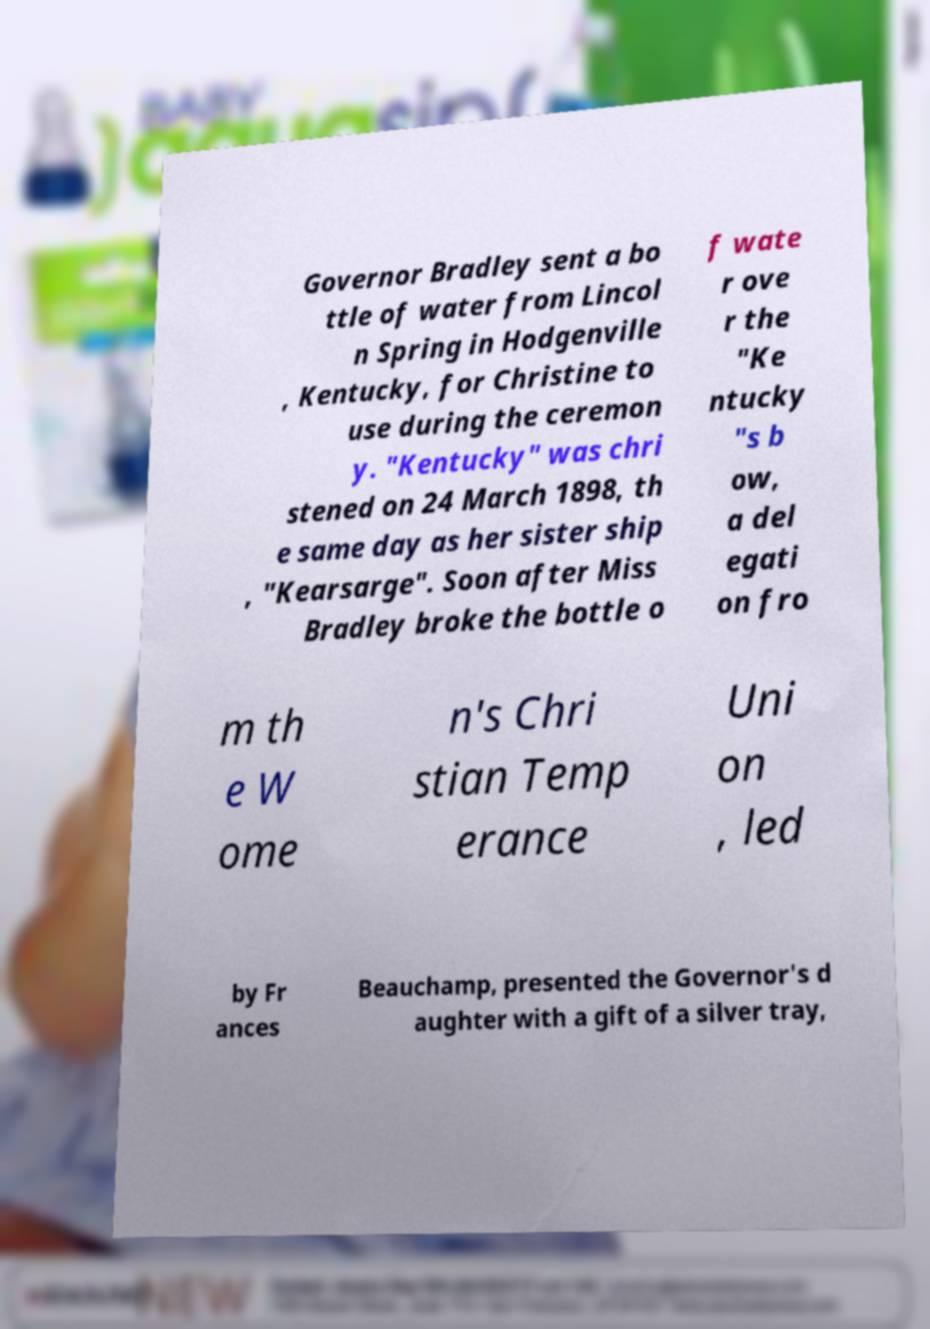Please read and relay the text visible in this image. What does it say? Governor Bradley sent a bo ttle of water from Lincol n Spring in Hodgenville , Kentucky, for Christine to use during the ceremon y. "Kentucky" was chri stened on 24 March 1898, th e same day as her sister ship , "Kearsarge". Soon after Miss Bradley broke the bottle o f wate r ove r the "Ke ntucky "s b ow, a del egati on fro m th e W ome n's Chri stian Temp erance Uni on , led by Fr ances Beauchamp, presented the Governor's d aughter with a gift of a silver tray, 